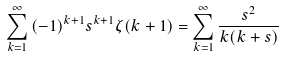<formula> <loc_0><loc_0><loc_500><loc_500>\sum _ { k = 1 } ^ { \infty } { ( - 1 ) ^ { k + 1 } s ^ { k + 1 } \zeta ( k + 1 ) } = \sum _ { k = 1 } ^ { \infty } { \frac { s ^ { 2 } } { k ( k + s ) } }</formula> 